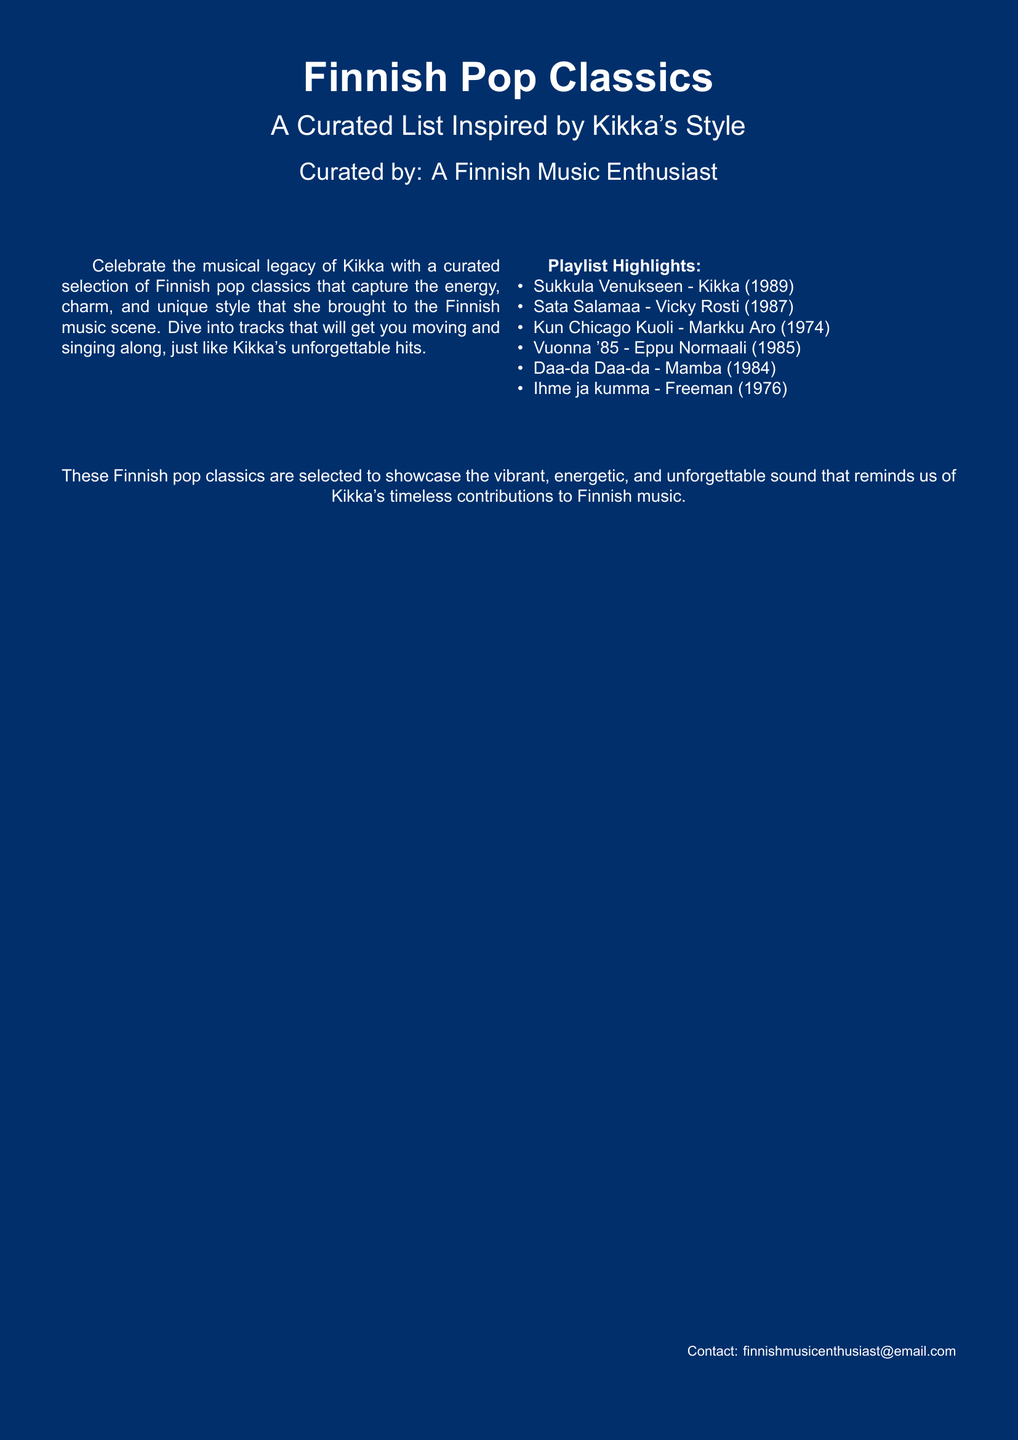What is the title of the document? The title of the document is prominently displayed at the top, indicating the focus on Finnish pop classics.
Answer: Finnish Pop Classics Who curated the playlist? The document specifies who curated the playlist, which is mentioned at the bottom of the title section.
Answer: A Finnish Music Enthusiast Which song is by Kikka? One of the songs listed in the playlist is specified as being performed by Kikka, highlighting her legacy.
Answer: Sukkula Venukseen How many songs are listed in the playlist? The document contains a bulleted list of songs, from which we can count the total number included.
Answer: 6 What year was "Sata Salamaa" released? The document provides the release year for each song, including this specific title.
Answer: 1987 What color is the background of the document? The document's use of color is indicated at the beginning, describing the page color chosen for the design.
Answer: Finnish Blue What is the email contact provided? The contact information for inquiries is clearly stated in the lower right corner of the document.
Answer: finnishmusicenthusiast@email.com What type of music does this document focus on? The document specifies the genre of music that the curated list is centered around.
Answer: Finnish pop classics 